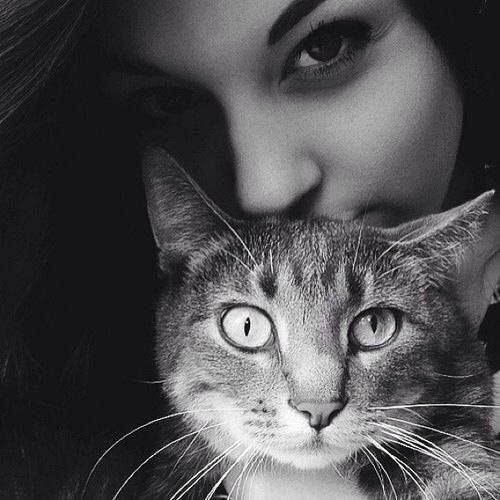How many eyes does the cat have?
Short answer required. 2. Does the lady like cats?
Answer briefly. Yes. What animal is present?
Short answer required. Cat. 